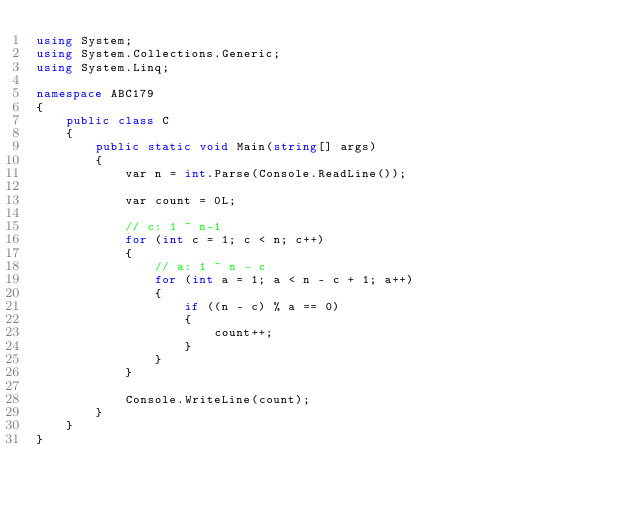Convert code to text. <code><loc_0><loc_0><loc_500><loc_500><_C#_>using System;
using System.Collections.Generic;
using System.Linq;

namespace ABC179
{
    public class C
    {
        public static void Main(string[] args)
        {
            var n = int.Parse(Console.ReadLine());

            var count = 0L;

            // c: 1 ~ n-1
            for (int c = 1; c < n; c++)
            {
                // a: 1 ~ n - c
                for (int a = 1; a < n - c + 1; a++)
                {
                    if ((n - c) % a == 0)
                    {
                        count++;
                    }
                }
            }

            Console.WriteLine(count);
        }
    }
}
</code> 